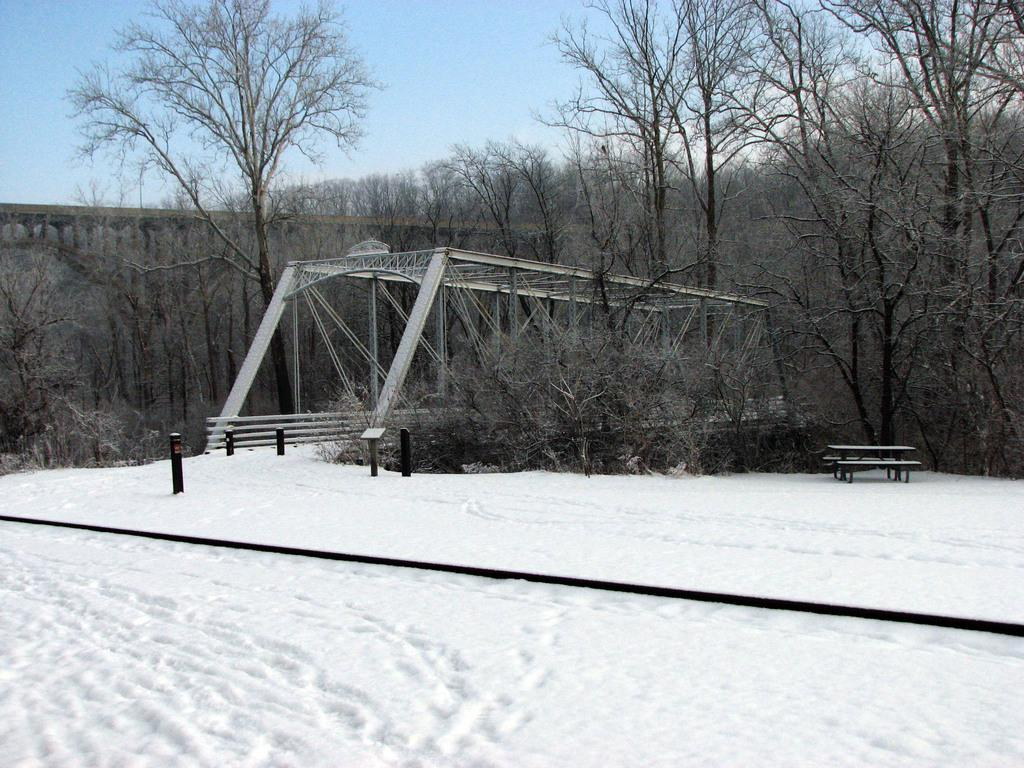What is covering the ground in the image? There is snow on the ground in the image. What structure can be seen in the image? There is a bridge in the image. What type of vegetation is present in the image? There are trees in the image. What type of seating is available in the image? There is a bench on the side in the image. How would you describe the sky in the image? The sky is blue and cloudy in the image. What type of beef is being served in the image? There is no beef present in the image; it features snow, a bridge, trees, a bench, and a blue and cloudy sky. What fictional character can be seen interacting with the trees in the image? There are no fictional characters present in the image; it features snow, a bridge, trees, a bench, and a blue and cloudy sky. 